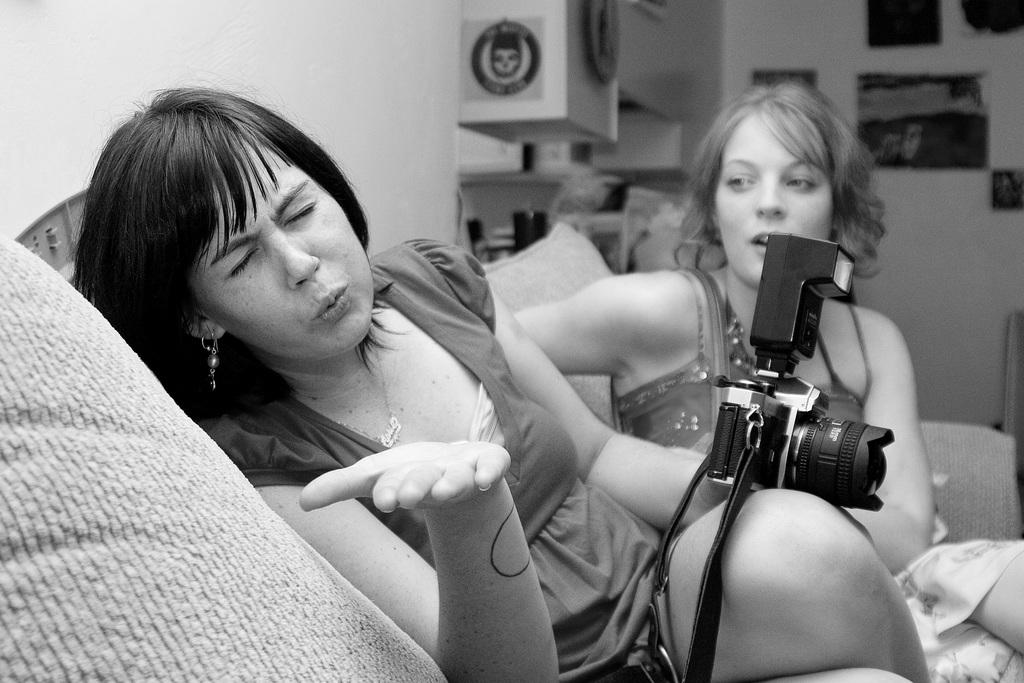Who is the main subject in the image? There is a girl in the center of the image. Can you describe the position of the second girl in the image? There is another girl behind her. What can be seen on the wall in the image? There are posters on the wall. What type of furniture is visible at the top side of the image? There are shelves at the top side of the image. What type of music is being played in the background of the image? There is no indication of music being played in the image; it only shows two girls and the surrounding environment. 